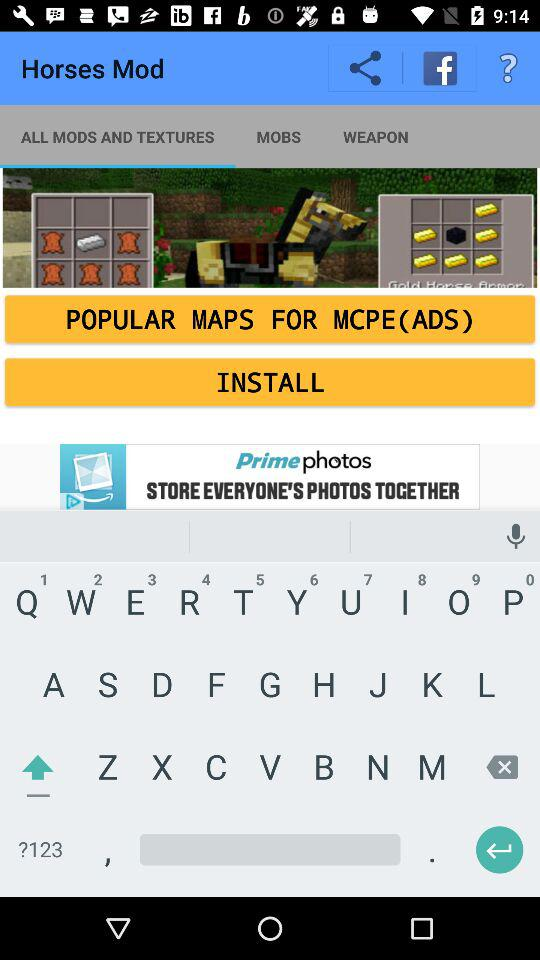How many more crafting ingredients are required for a Gold Horse Armor than for a Saddle?
Answer the question using a single word or phrase. 1 